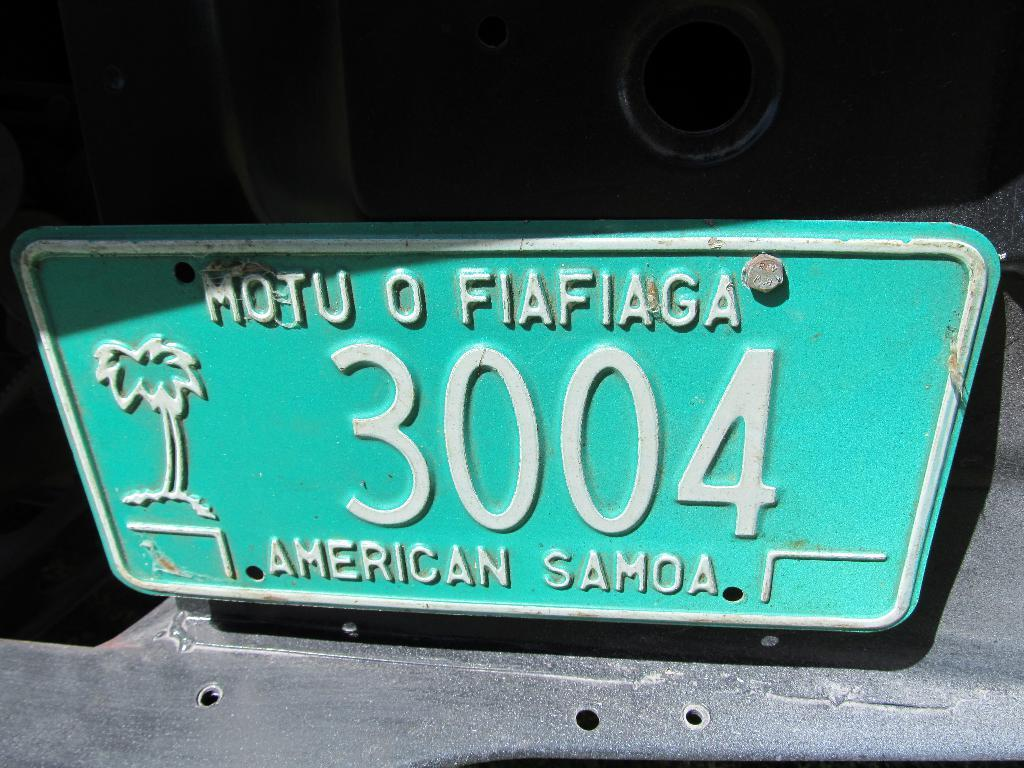<image>
Provide a brief description of the given image. A green and white license plate that comes from american samoa with a palm tree on the left. 